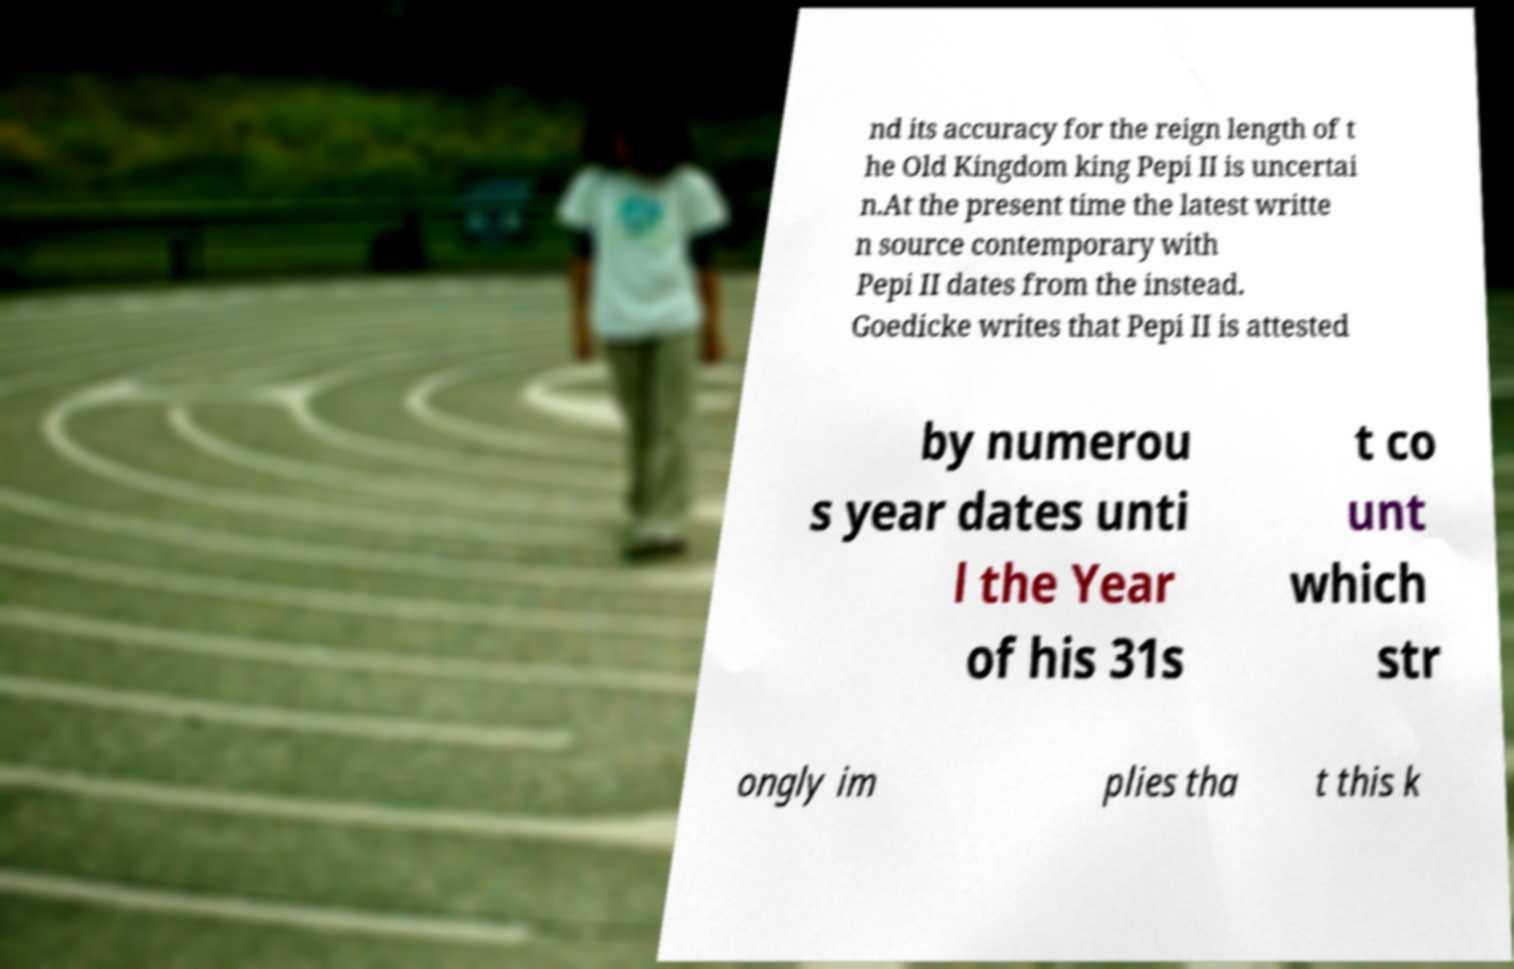Please read and relay the text visible in this image. What does it say? nd its accuracy for the reign length of t he Old Kingdom king Pepi II is uncertai n.At the present time the latest writte n source contemporary with Pepi II dates from the instead. Goedicke writes that Pepi II is attested by numerou s year dates unti l the Year of his 31s t co unt which str ongly im plies tha t this k 